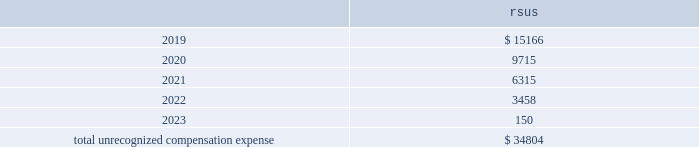We have not capitalized any stock-based compensation costs during the years ended december 31 , 2018 , 2017 , and as of december 31 , 2018 , unrecognized compensation expense related to unvested rsus is expected to be recognized as follows ( in thousands ) : .
Stock-based compensation expense related to these awards will be different to the extent that forfeitures are realized. .
In 2018 what was the percent of the total unrecognized compensation expense due in 2020? 
Computations: (9715 / 34804)
Answer: 0.27913. 